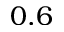<formula> <loc_0><loc_0><loc_500><loc_500>0 . 6</formula> 